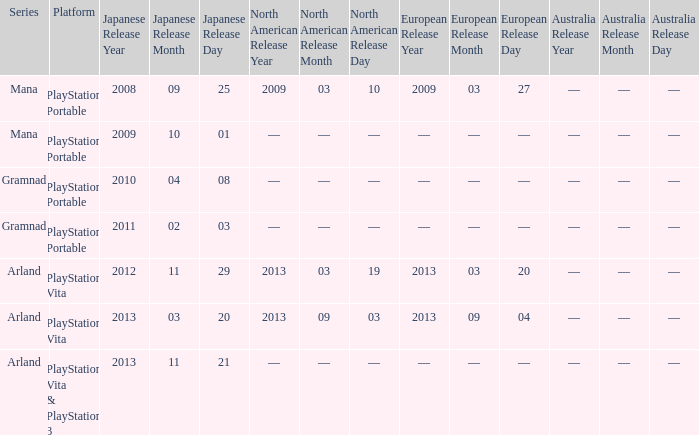What is the series with a North American release date on 2013-09-03? Arland. 